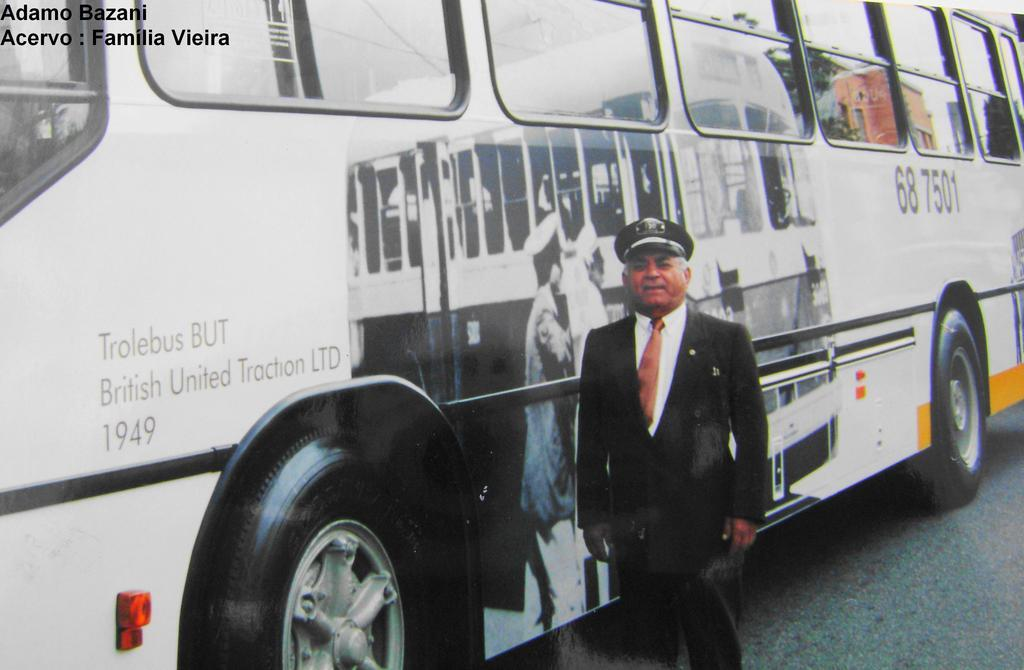Provide a one-sentence caption for the provided image. A man stands outside of the Trolebus BUT. 